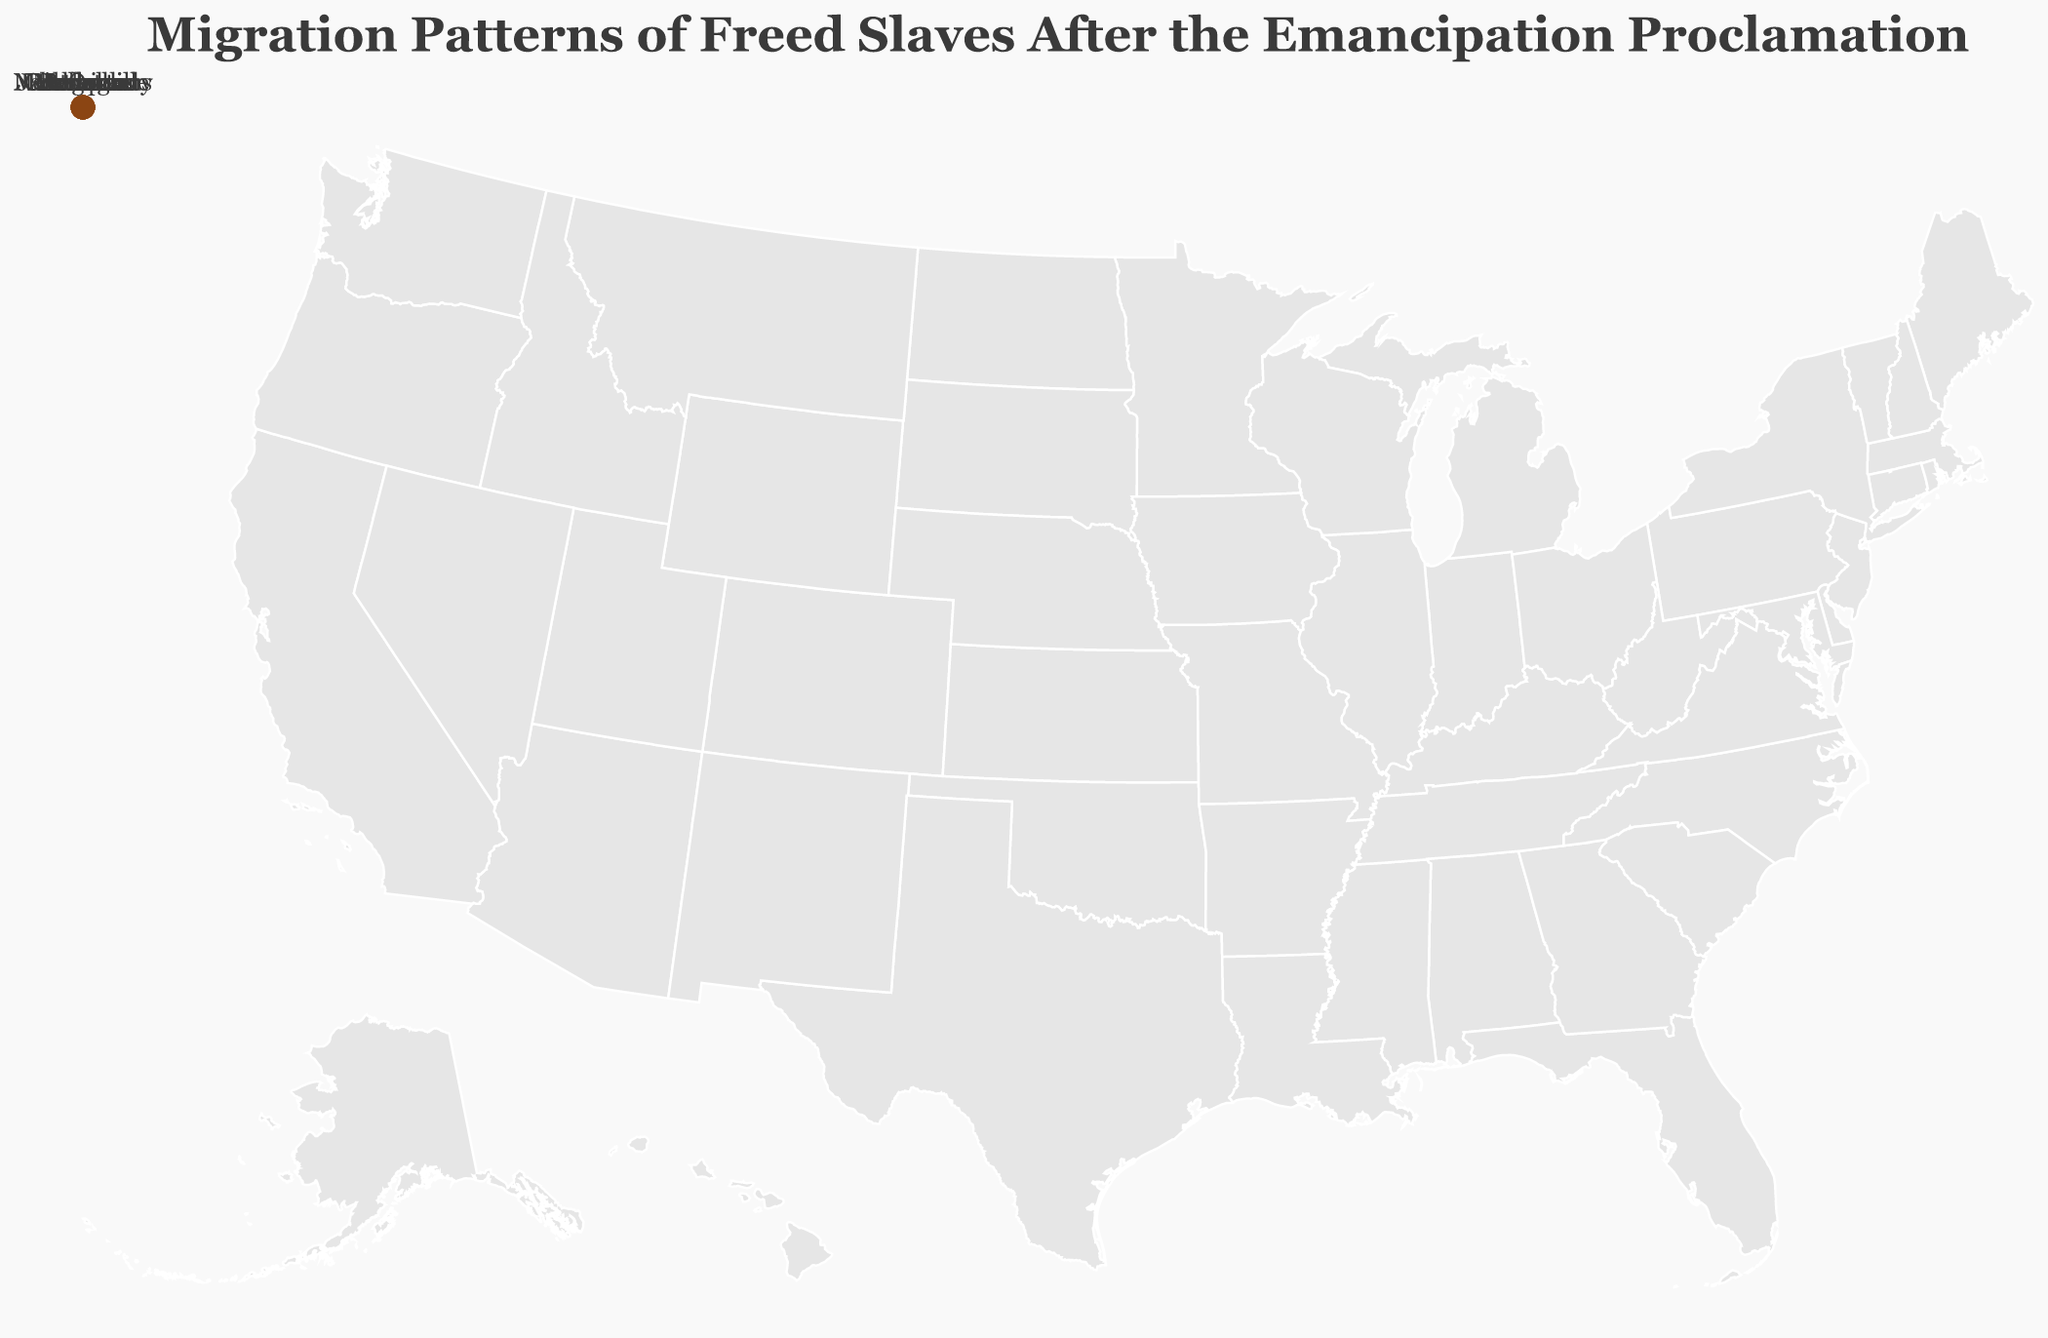What is the title of the figure? The title is located at the top of the figure, typically in a larger font to grab attention.
Answer: Migration Patterns of Freed Slaves After the Emancipation Proclamation Which route shows the highest number of migrants? By examining all migration routes and their respective numbers, the highest number is linked to the route from Richmond to Philadelphia, which has 5000 migrants.
Answer: Richmond to Philadelphia What is the sum of migrants from Richmond, Atlanta, and Charleston? Adding the number of migrants from the three cities: 5000 (Richmond) + 3500 (Atlanta) + 4200 (Charleston) equals 12700.
Answer: 12700 Which Northern city received the largest number of migrants from Southern states? Reviewing each destination city's number of migrants, Philadelphia received the largest number with 5000 migrants.
Answer: Philadelphia How many Southern states are represented in the migration data? Each unique originating location represents a different Southern state. Counting them, there are 10 unique states.
Answer: 10 How does the number of migrants moving from New Orleans to Boston compare to those moving from Memphis to St. Louis? Comparing the two numbers, New Orleans to Boston has 3800 migrants, whereas Memphis to St. Louis has 3300 migrants. Therefore, New Orleans to Boston has more migrants.
Answer: New Orleans to Boston What is the average number of migrants per route? Adding all the migrants across routes (5000 + 3500 + 4200 + 2800 + 3100 + 3800 + 2600 + 3300 + 2200 + 2900) gives 33400. Dividing this by the total number of routes (10) equals an average of 3340 migrants per route.
Answer: 3340 Which Southern city had the fewest migrants? By examining the number of migrants for all Southern cities, Jacksonville had the fewest with 2200 migrants.
Answer: Jacksonville Which city pair shows the most significant migration path length? While the exact geographical measurement isn't provided, the longest apparent route visually stretches from New Orleans to Boston.
Answer: New Orleans to Boston What is the color used for the migration circles? By observing the color used for the circles indicating migration, it appears to be a brownish shade.
Answer: Brown 